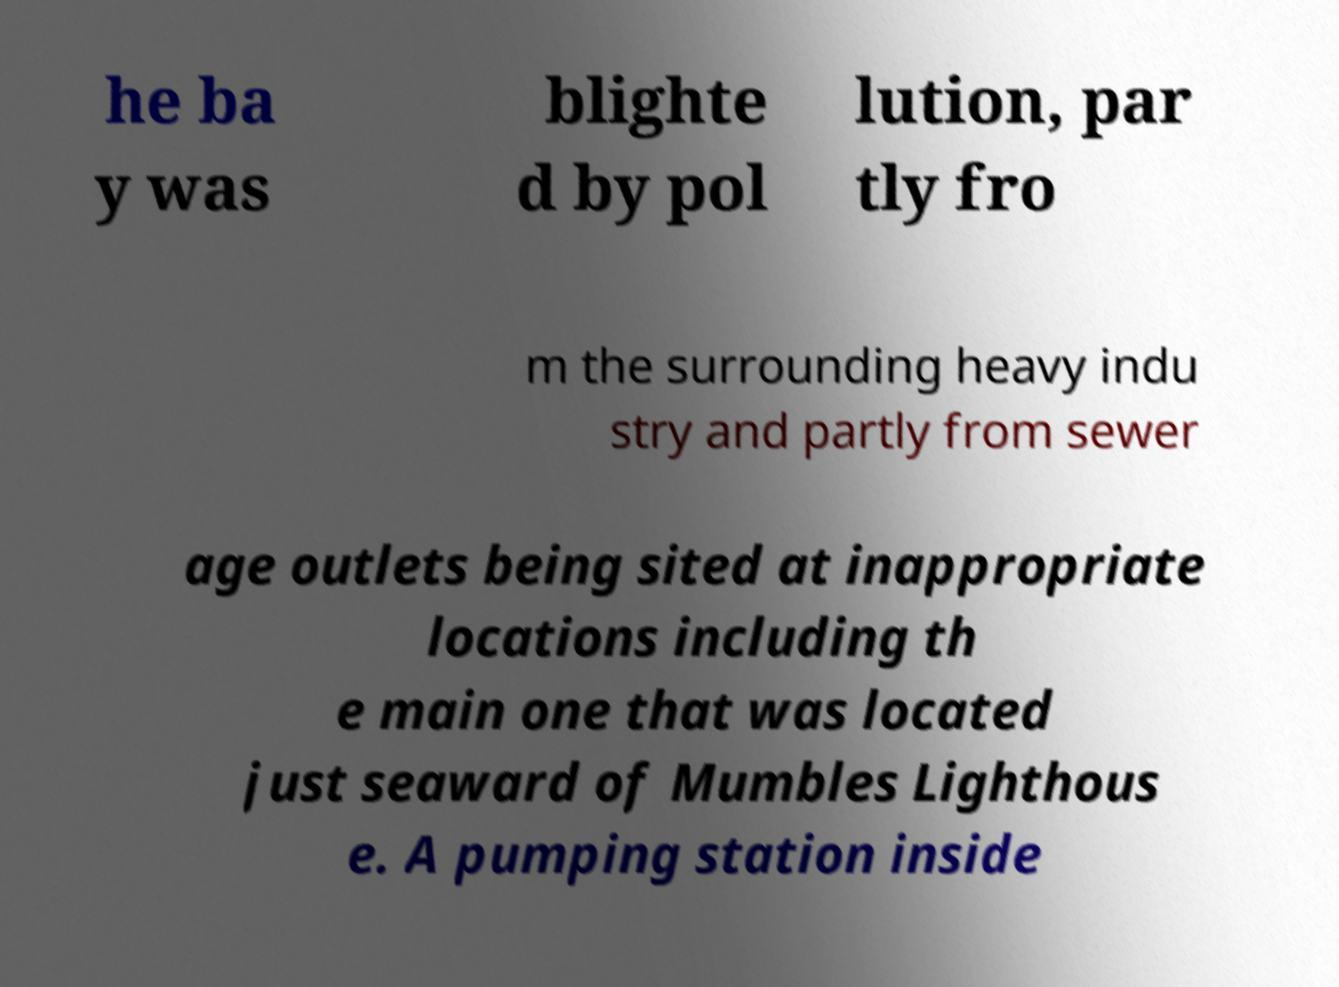Could you assist in decoding the text presented in this image and type it out clearly? he ba y was blighte d by pol lution, par tly fro m the surrounding heavy indu stry and partly from sewer age outlets being sited at inappropriate locations including th e main one that was located just seaward of Mumbles Lighthous e. A pumping station inside 